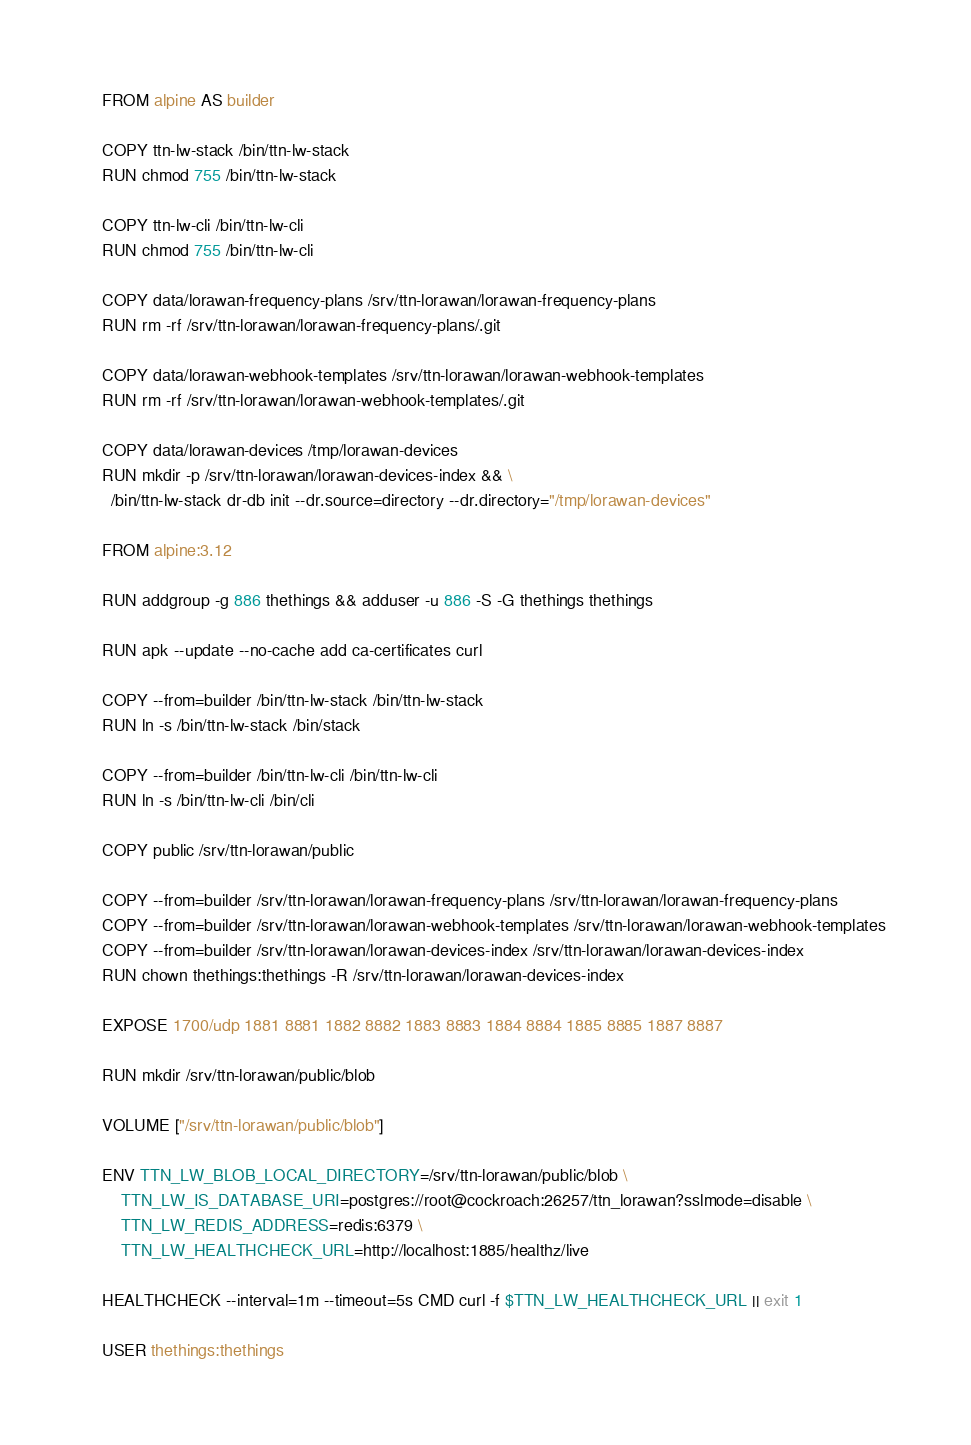<code> <loc_0><loc_0><loc_500><loc_500><_Dockerfile_>FROM alpine AS builder

COPY ttn-lw-stack /bin/ttn-lw-stack
RUN chmod 755 /bin/ttn-lw-stack

COPY ttn-lw-cli /bin/ttn-lw-cli
RUN chmod 755 /bin/ttn-lw-cli

COPY data/lorawan-frequency-plans /srv/ttn-lorawan/lorawan-frequency-plans
RUN rm -rf /srv/ttn-lorawan/lorawan-frequency-plans/.git

COPY data/lorawan-webhook-templates /srv/ttn-lorawan/lorawan-webhook-templates
RUN rm -rf /srv/ttn-lorawan/lorawan-webhook-templates/.git

COPY data/lorawan-devices /tmp/lorawan-devices
RUN mkdir -p /srv/ttn-lorawan/lorawan-devices-index && \
  /bin/ttn-lw-stack dr-db init --dr.source=directory --dr.directory="/tmp/lorawan-devices"

FROM alpine:3.12

RUN addgroup -g 886 thethings && adduser -u 886 -S -G thethings thethings

RUN apk --update --no-cache add ca-certificates curl

COPY --from=builder /bin/ttn-lw-stack /bin/ttn-lw-stack
RUN ln -s /bin/ttn-lw-stack /bin/stack

COPY --from=builder /bin/ttn-lw-cli /bin/ttn-lw-cli
RUN ln -s /bin/ttn-lw-cli /bin/cli

COPY public /srv/ttn-lorawan/public

COPY --from=builder /srv/ttn-lorawan/lorawan-frequency-plans /srv/ttn-lorawan/lorawan-frequency-plans
COPY --from=builder /srv/ttn-lorawan/lorawan-webhook-templates /srv/ttn-lorawan/lorawan-webhook-templates
COPY --from=builder /srv/ttn-lorawan/lorawan-devices-index /srv/ttn-lorawan/lorawan-devices-index
RUN chown thethings:thethings -R /srv/ttn-lorawan/lorawan-devices-index

EXPOSE 1700/udp 1881 8881 1882 8882 1883 8883 1884 8884 1885 8885 1887 8887

RUN mkdir /srv/ttn-lorawan/public/blob

VOLUME ["/srv/ttn-lorawan/public/blob"]

ENV TTN_LW_BLOB_LOCAL_DIRECTORY=/srv/ttn-lorawan/public/blob \
    TTN_LW_IS_DATABASE_URI=postgres://root@cockroach:26257/ttn_lorawan?sslmode=disable \
    TTN_LW_REDIS_ADDRESS=redis:6379 \
    TTN_LW_HEALTHCHECK_URL=http://localhost:1885/healthz/live

HEALTHCHECK --interval=1m --timeout=5s CMD curl -f $TTN_LW_HEALTHCHECK_URL || exit 1

USER thethings:thethings
</code> 